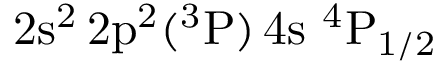<formula> <loc_0><loc_0><loc_500><loc_500>2 s ^ { 2 } \, 2 p ^ { 2 } ( ^ { 3 } P ) \, 4 s ^ { 4 } P _ { 1 / 2 }</formula> 